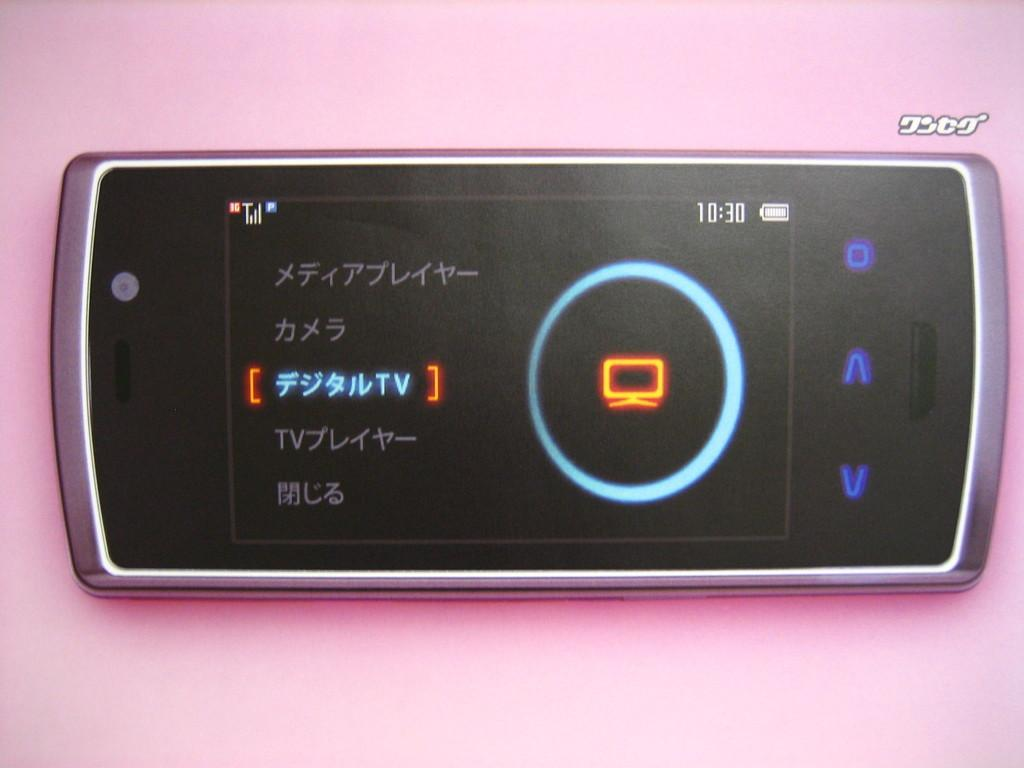What color is the background of the image? The background of the image is pink. What object is present in the image that displays time? There is a gadget in the image that displays time. Does the gadget have any indication of battery status? Yes, the gadget has a battery icon. What type of information is visible on the gadget besides time? There is some language text visible on the gadget. What type of sticks are used to stir the soda in the image? There is no soda or sticks present in the image. What nation is represented by the flag on the gadget in the image? There is no flag visible on the gadget in the image. 